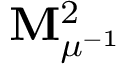<formula> <loc_0><loc_0><loc_500><loc_500>M _ { \mu ^ { - 1 } } ^ { 2 }</formula> 